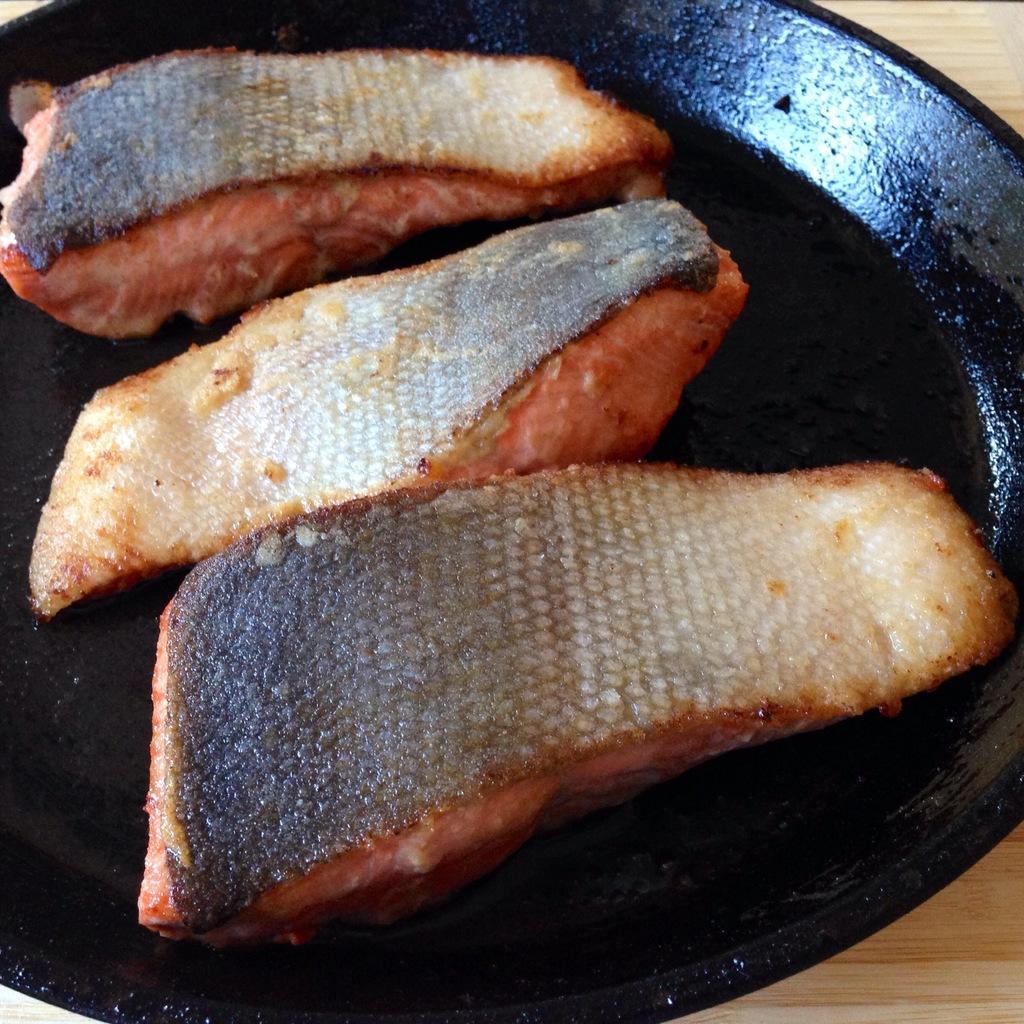How would you summarize this image in a sentence or two? In this image we can see food items in a black color pan on the wooden surface. 